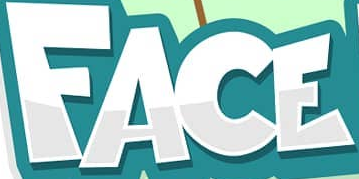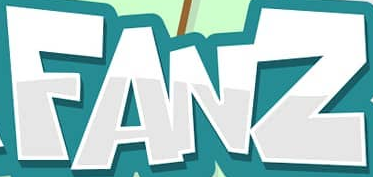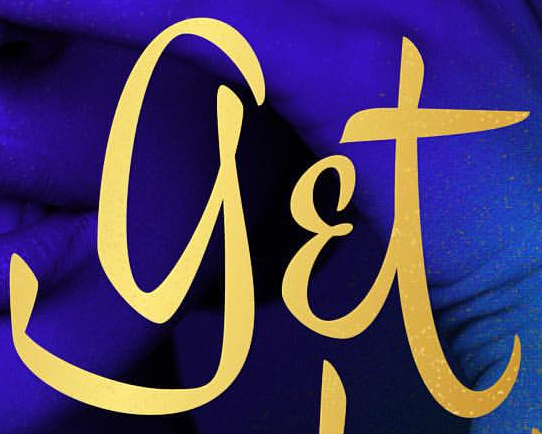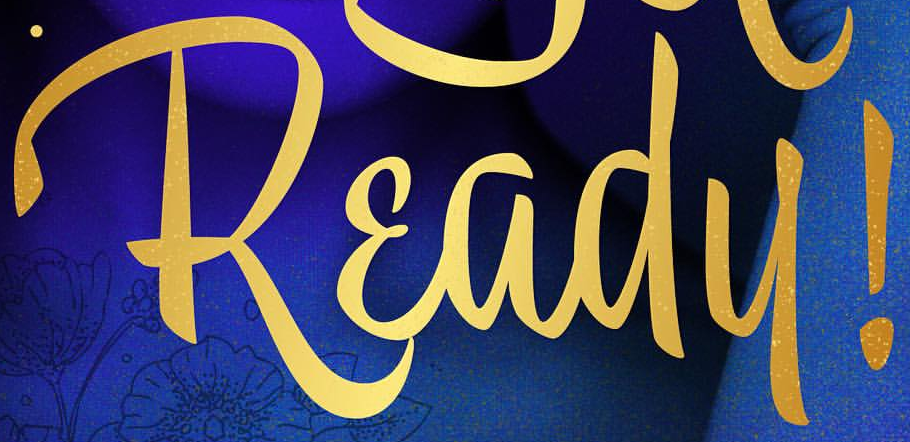What words are shown in these images in order, separated by a semicolon? FACE; FANZ; get; Ready! 